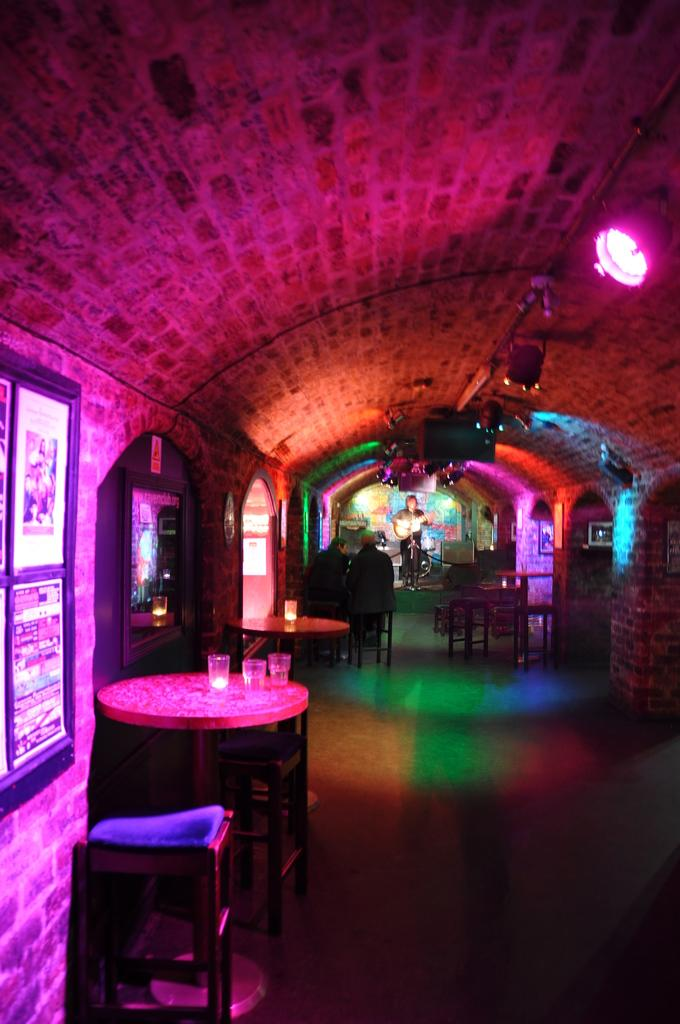What type of furniture is present in the image? There are tables in the image. What objects are placed on the tables? There are glasses on the tables. What can be used for sitting near the tables? Chairs are present beside the tables. What type of lighting is visible in the image? Colorful lights are visible in the image. What type of decorations are on the walls? There are portraits on the walls. What type of hook is hanging from the ceiling in the image? There is no hook hanging from the ceiling in the image. What emotion is the person in the portrait feeling? The emotion of the person in the portrait cannot be determined from the image alone. 